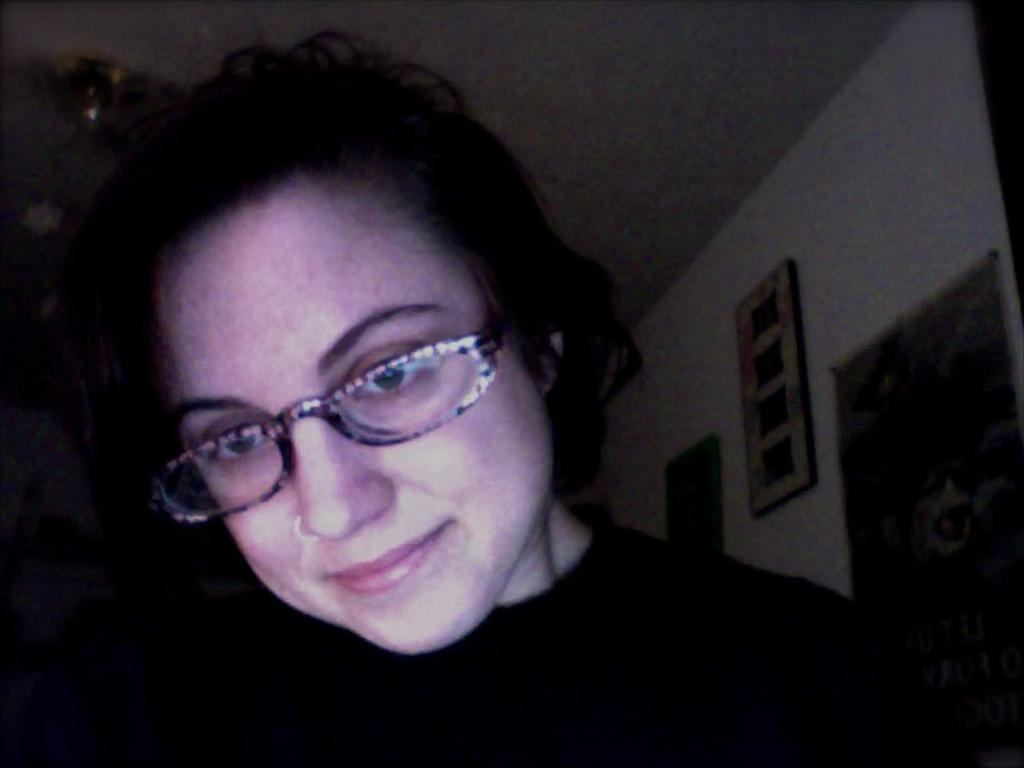Who is the main subject in the image? There is a lady in the center of the image. What can be seen in the background of the image? There are portraits on the wall in the background of the image. What type of grass is growing on the lady's trousers in the image? There is no grass or trousers present in the image; the lady is not wearing any trousers, and there is no grass visible. 